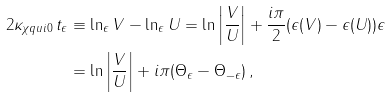<formula> <loc_0><loc_0><loc_500><loc_500>2 \kappa _ { \chi q u i { 0 } } \, t _ { \epsilon } & \equiv \ln _ { \epsilon } V - \ln _ { \epsilon } U = \ln \left | \frac { V } { U } \right | + \frac { i \pi } { 2 } ( \epsilon ( V ) - \epsilon ( U ) ) \epsilon \\ & = \ln \left | \frac { V } { U } \right | + i \pi ( \Theta _ { \epsilon } - \Theta _ { - \epsilon } ) \, ,</formula> 